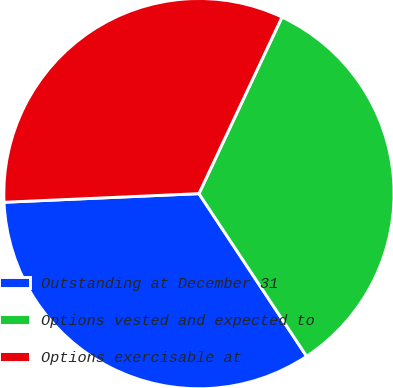Convert chart. <chart><loc_0><loc_0><loc_500><loc_500><pie_chart><fcel>Outstanding at December 31<fcel>Options vested and expected to<fcel>Options exercisable at<nl><fcel>33.6%<fcel>33.69%<fcel>32.7%<nl></chart> 